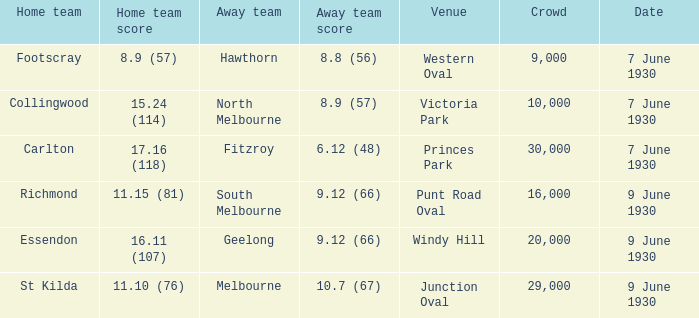What is the away team that scored 9.12 (66) at Windy Hill? Geelong. 